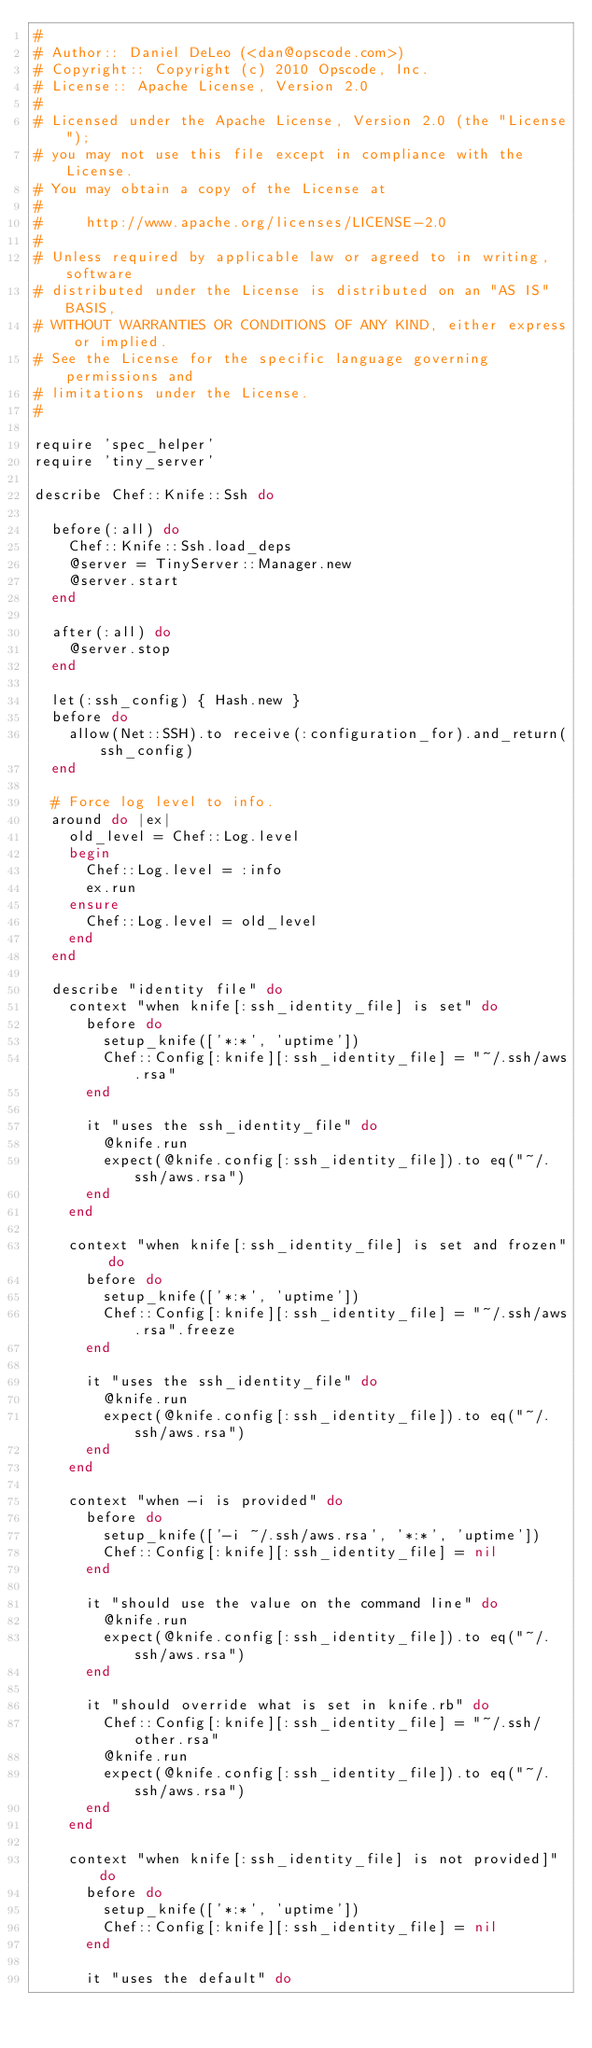<code> <loc_0><loc_0><loc_500><loc_500><_Ruby_>#
# Author:: Daniel DeLeo (<dan@opscode.com>)
# Copyright:: Copyright (c) 2010 Opscode, Inc.
# License:: Apache License, Version 2.0
#
# Licensed under the Apache License, Version 2.0 (the "License");
# you may not use this file except in compliance with the License.
# You may obtain a copy of the License at
#
#     http://www.apache.org/licenses/LICENSE-2.0
#
# Unless required by applicable law or agreed to in writing, software
# distributed under the License is distributed on an "AS IS" BASIS,
# WITHOUT WARRANTIES OR CONDITIONS OF ANY KIND, either express or implied.
# See the License for the specific language governing permissions and
# limitations under the License.
#

require 'spec_helper'
require 'tiny_server'

describe Chef::Knife::Ssh do

  before(:all) do
    Chef::Knife::Ssh.load_deps
    @server = TinyServer::Manager.new
    @server.start
  end

  after(:all) do
    @server.stop
  end

  let(:ssh_config) { Hash.new }
  before do
    allow(Net::SSH).to receive(:configuration_for).and_return(ssh_config)
  end

  # Force log level to info.
  around do |ex|
    old_level = Chef::Log.level
    begin
      Chef::Log.level = :info
      ex.run
    ensure
      Chef::Log.level = old_level
    end
  end

  describe "identity file" do
    context "when knife[:ssh_identity_file] is set" do
      before do
        setup_knife(['*:*', 'uptime'])
        Chef::Config[:knife][:ssh_identity_file] = "~/.ssh/aws.rsa"
      end

      it "uses the ssh_identity_file" do
        @knife.run
        expect(@knife.config[:ssh_identity_file]).to eq("~/.ssh/aws.rsa")
      end
    end

    context "when knife[:ssh_identity_file] is set and frozen" do
      before do
        setup_knife(['*:*', 'uptime'])
        Chef::Config[:knife][:ssh_identity_file] = "~/.ssh/aws.rsa".freeze
      end

      it "uses the ssh_identity_file" do
        @knife.run
        expect(@knife.config[:ssh_identity_file]).to eq("~/.ssh/aws.rsa")
      end
    end

    context "when -i is provided" do
      before do
        setup_knife(['-i ~/.ssh/aws.rsa', '*:*', 'uptime'])
        Chef::Config[:knife][:ssh_identity_file] = nil
      end

      it "should use the value on the command line" do
        @knife.run
        expect(@knife.config[:ssh_identity_file]).to eq("~/.ssh/aws.rsa")
      end

      it "should override what is set in knife.rb" do
        Chef::Config[:knife][:ssh_identity_file] = "~/.ssh/other.rsa"
        @knife.run
        expect(@knife.config[:ssh_identity_file]).to eq("~/.ssh/aws.rsa")
      end
    end

    context "when knife[:ssh_identity_file] is not provided]" do
      before do
        setup_knife(['*:*', 'uptime'])
        Chef::Config[:knife][:ssh_identity_file] = nil
      end

      it "uses the default" do</code> 